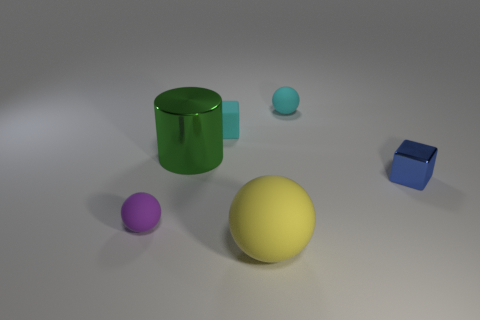What material is the cube that is behind the blue block?
Offer a very short reply. Rubber. Is the number of small blue shiny objects in front of the tiny purple matte sphere the same as the number of things that are on the right side of the big metallic cylinder?
Give a very brief answer. No. There is a matte object that is in front of the tiny purple thing; does it have the same size as the matte ball left of the large yellow thing?
Give a very brief answer. No. What number of matte blocks have the same color as the big rubber thing?
Give a very brief answer. 0. Is the number of small matte objects behind the small purple object greater than the number of big green cylinders?
Your answer should be very brief. Yes. Is the purple matte thing the same shape as the big matte object?
Your answer should be compact. Yes. What number of large yellow objects have the same material as the tiny cyan sphere?
Offer a terse response. 1. What is the size of the yellow object that is the same shape as the small purple rubber thing?
Your answer should be compact. Large. Do the metal block and the cyan block have the same size?
Keep it short and to the point. Yes. There is a rubber thing behind the cube that is behind the metal object that is to the left of the large sphere; what is its shape?
Make the answer very short. Sphere. 